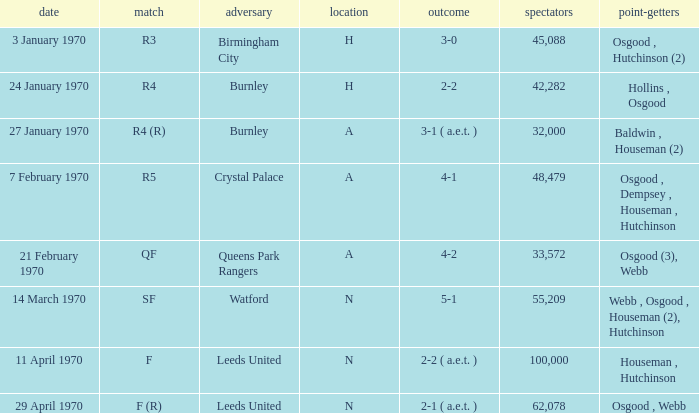What round was the game with a result of 5-1 at N venue? SF. Could you parse the entire table? {'header': ['date', 'match', 'adversary', 'location', 'outcome', 'spectators', 'point-getters'], 'rows': [['3 January 1970', 'R3', 'Birmingham City', 'H', '3-0', '45,088', 'Osgood , Hutchinson (2)'], ['24 January 1970', 'R4', 'Burnley', 'H', '2-2', '42,282', 'Hollins , Osgood'], ['27 January 1970', 'R4 (R)', 'Burnley', 'A', '3-1 ( a.e.t. )', '32,000', 'Baldwin , Houseman (2)'], ['7 February 1970', 'R5', 'Crystal Palace', 'A', '4-1', '48,479', 'Osgood , Dempsey , Houseman , Hutchinson'], ['21 February 1970', 'QF', 'Queens Park Rangers', 'A', '4-2', '33,572', 'Osgood (3), Webb'], ['14 March 1970', 'SF', 'Watford', 'N', '5-1', '55,209', 'Webb , Osgood , Houseman (2), Hutchinson'], ['11 April 1970', 'F', 'Leeds United', 'N', '2-2 ( a.e.t. )', '100,000', 'Houseman , Hutchinson'], ['29 April 1970', 'F (R)', 'Leeds United', 'N', '2-1 ( a.e.t. )', '62,078', 'Osgood , Webb']]} 